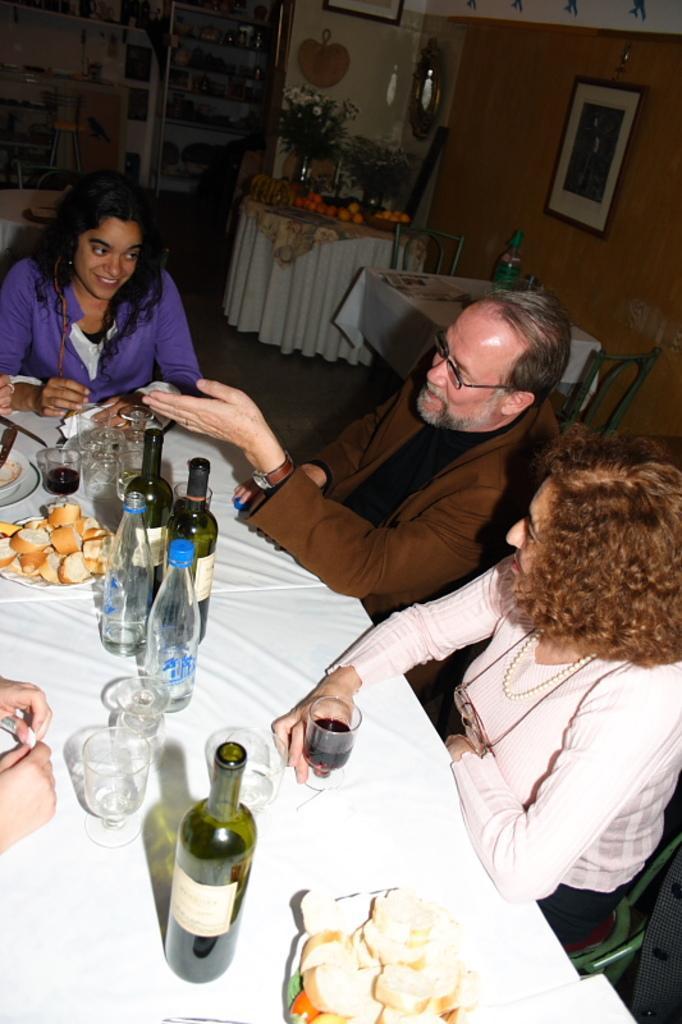In one or two sentences, can you explain what this image depicts? In this image I can see three person sitting on the chair. On the table there is food,wine bottle,glass,water bottle and the table is covered with the white cloth. At the back side I can see a fruits,flower pot. On the wall there are frames and a mirror. There is shelf. The wall is in brown color. 